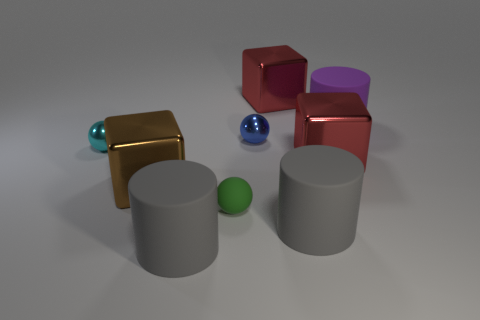There is a metallic sphere that is on the right side of the big matte thing left of the small metal ball that is on the right side of the small green matte thing; what color is it?
Your answer should be very brief. Blue. How many yellow objects are tiny spheres or small shiny things?
Keep it short and to the point. 0. How many red things have the same shape as the brown shiny thing?
Your answer should be compact. 2. There is a brown thing that is the same size as the purple matte object; what is its shape?
Your answer should be very brief. Cube. Are there any large objects in front of the tiny blue sphere?
Your answer should be very brief. Yes. There is a large red metallic thing that is behind the purple thing; are there any tiny objects that are behind it?
Offer a terse response. No. Are there fewer blue metallic balls in front of the cyan thing than red cubes in front of the large purple cylinder?
Make the answer very short. Yes. Are there any other things that have the same size as the purple matte cylinder?
Your response must be concise. Yes. The purple thing has what shape?
Ensure brevity in your answer.  Cylinder. What is the big red block behind the large purple cylinder made of?
Your answer should be very brief. Metal. 